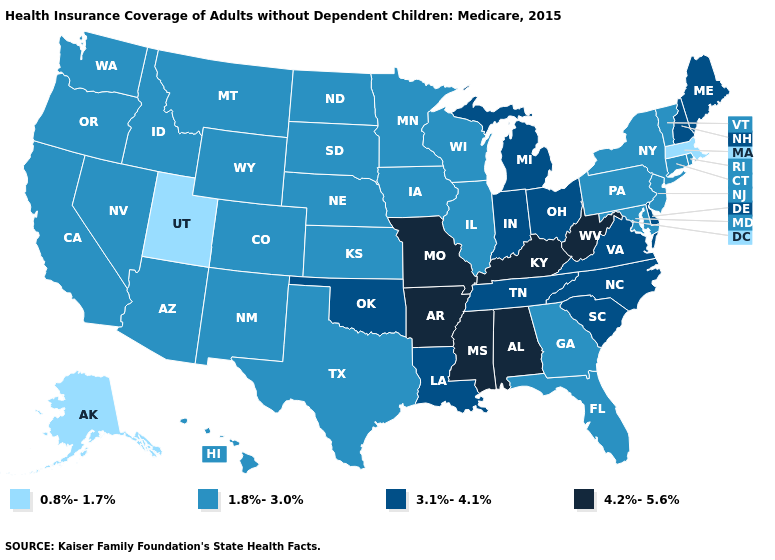Which states have the highest value in the USA?
Concise answer only. Alabama, Arkansas, Kentucky, Mississippi, Missouri, West Virginia. Is the legend a continuous bar?
Give a very brief answer. No. Does Wisconsin have the highest value in the MidWest?
Short answer required. No. What is the value of North Carolina?
Answer briefly. 3.1%-4.1%. What is the lowest value in states that border New York?
Answer briefly. 0.8%-1.7%. What is the lowest value in the West?
Quick response, please. 0.8%-1.7%. What is the value of New Jersey?
Give a very brief answer. 1.8%-3.0%. What is the value of Alabama?
Concise answer only. 4.2%-5.6%. What is the value of Kansas?
Keep it brief. 1.8%-3.0%. Name the states that have a value in the range 0.8%-1.7%?
Quick response, please. Alaska, Massachusetts, Utah. How many symbols are there in the legend?
Write a very short answer. 4. What is the value of Pennsylvania?
Answer briefly. 1.8%-3.0%. Does Mississippi have the same value as West Virginia?
Keep it brief. Yes. How many symbols are there in the legend?
Write a very short answer. 4. 